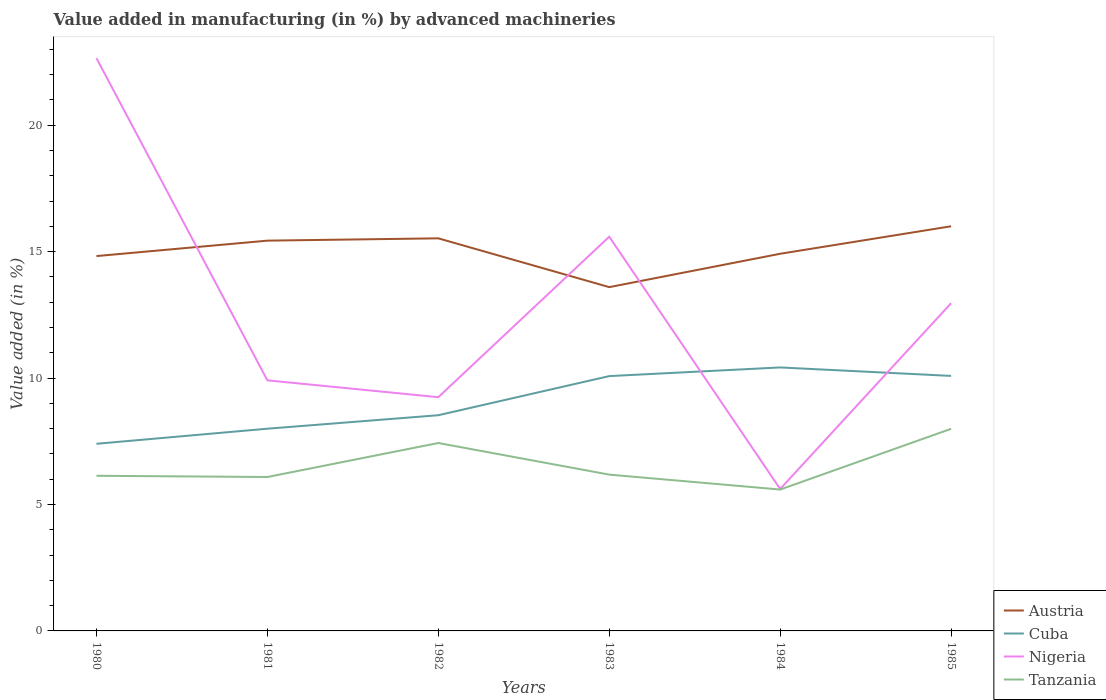How many different coloured lines are there?
Your answer should be very brief. 4. Is the number of lines equal to the number of legend labels?
Your answer should be very brief. Yes. Across all years, what is the maximum percentage of value added in manufacturing by advanced machineries in Cuba?
Your answer should be very brief. 7.4. What is the total percentage of value added in manufacturing by advanced machineries in Tanzania in the graph?
Provide a short and direct response. 0.54. What is the difference between the highest and the second highest percentage of value added in manufacturing by advanced machineries in Tanzania?
Make the answer very short. 2.4. Is the percentage of value added in manufacturing by advanced machineries in Austria strictly greater than the percentage of value added in manufacturing by advanced machineries in Tanzania over the years?
Provide a succinct answer. No. How many lines are there?
Ensure brevity in your answer.  4. How many years are there in the graph?
Your answer should be very brief. 6. What is the difference between two consecutive major ticks on the Y-axis?
Provide a succinct answer. 5. Are the values on the major ticks of Y-axis written in scientific E-notation?
Your response must be concise. No. Does the graph contain any zero values?
Give a very brief answer. No. Where does the legend appear in the graph?
Ensure brevity in your answer.  Bottom right. How many legend labels are there?
Ensure brevity in your answer.  4. What is the title of the graph?
Give a very brief answer. Value added in manufacturing (in %) by advanced machineries. Does "Cote d'Ivoire" appear as one of the legend labels in the graph?
Keep it short and to the point. No. What is the label or title of the Y-axis?
Keep it short and to the point. Value added (in %). What is the Value added (in %) of Austria in 1980?
Ensure brevity in your answer.  14.82. What is the Value added (in %) of Cuba in 1980?
Provide a short and direct response. 7.4. What is the Value added (in %) in Nigeria in 1980?
Your answer should be compact. 22.65. What is the Value added (in %) of Tanzania in 1980?
Provide a succinct answer. 6.14. What is the Value added (in %) of Austria in 1981?
Make the answer very short. 15.43. What is the Value added (in %) of Cuba in 1981?
Your response must be concise. 8. What is the Value added (in %) of Nigeria in 1981?
Your response must be concise. 9.91. What is the Value added (in %) in Tanzania in 1981?
Keep it short and to the point. 6.09. What is the Value added (in %) in Austria in 1982?
Your response must be concise. 15.53. What is the Value added (in %) in Cuba in 1982?
Your answer should be very brief. 8.53. What is the Value added (in %) of Nigeria in 1982?
Keep it short and to the point. 9.24. What is the Value added (in %) of Tanzania in 1982?
Offer a very short reply. 7.43. What is the Value added (in %) in Austria in 1983?
Your response must be concise. 13.6. What is the Value added (in %) of Cuba in 1983?
Offer a very short reply. 10.08. What is the Value added (in %) of Nigeria in 1983?
Offer a very short reply. 15.59. What is the Value added (in %) in Tanzania in 1983?
Offer a very short reply. 6.18. What is the Value added (in %) in Austria in 1984?
Offer a very short reply. 14.92. What is the Value added (in %) of Cuba in 1984?
Make the answer very short. 10.42. What is the Value added (in %) of Nigeria in 1984?
Your answer should be very brief. 5.61. What is the Value added (in %) in Tanzania in 1984?
Keep it short and to the point. 5.59. What is the Value added (in %) of Austria in 1985?
Make the answer very short. 16. What is the Value added (in %) in Cuba in 1985?
Offer a terse response. 10.09. What is the Value added (in %) of Nigeria in 1985?
Make the answer very short. 12.96. What is the Value added (in %) of Tanzania in 1985?
Ensure brevity in your answer.  7.99. Across all years, what is the maximum Value added (in %) in Austria?
Your answer should be compact. 16. Across all years, what is the maximum Value added (in %) in Cuba?
Give a very brief answer. 10.42. Across all years, what is the maximum Value added (in %) in Nigeria?
Your answer should be very brief. 22.65. Across all years, what is the maximum Value added (in %) in Tanzania?
Provide a short and direct response. 7.99. Across all years, what is the minimum Value added (in %) of Austria?
Offer a very short reply. 13.6. Across all years, what is the minimum Value added (in %) in Cuba?
Keep it short and to the point. 7.4. Across all years, what is the minimum Value added (in %) in Nigeria?
Ensure brevity in your answer.  5.61. Across all years, what is the minimum Value added (in %) of Tanzania?
Offer a very short reply. 5.59. What is the total Value added (in %) in Austria in the graph?
Provide a short and direct response. 90.3. What is the total Value added (in %) in Cuba in the graph?
Your answer should be compact. 54.51. What is the total Value added (in %) of Nigeria in the graph?
Provide a short and direct response. 75.97. What is the total Value added (in %) of Tanzania in the graph?
Offer a very short reply. 39.42. What is the difference between the Value added (in %) of Austria in 1980 and that in 1981?
Offer a terse response. -0.61. What is the difference between the Value added (in %) of Cuba in 1980 and that in 1981?
Provide a short and direct response. -0.6. What is the difference between the Value added (in %) of Nigeria in 1980 and that in 1981?
Ensure brevity in your answer.  12.74. What is the difference between the Value added (in %) in Tanzania in 1980 and that in 1981?
Provide a succinct answer. 0.05. What is the difference between the Value added (in %) of Austria in 1980 and that in 1982?
Keep it short and to the point. -0.7. What is the difference between the Value added (in %) in Cuba in 1980 and that in 1982?
Your answer should be very brief. -1.13. What is the difference between the Value added (in %) in Nigeria in 1980 and that in 1982?
Your response must be concise. 13.41. What is the difference between the Value added (in %) of Tanzania in 1980 and that in 1982?
Your answer should be very brief. -1.3. What is the difference between the Value added (in %) of Austria in 1980 and that in 1983?
Provide a short and direct response. 1.23. What is the difference between the Value added (in %) in Cuba in 1980 and that in 1983?
Offer a very short reply. -2.68. What is the difference between the Value added (in %) in Nigeria in 1980 and that in 1983?
Keep it short and to the point. 7.06. What is the difference between the Value added (in %) of Tanzania in 1980 and that in 1983?
Make the answer very short. -0.05. What is the difference between the Value added (in %) in Austria in 1980 and that in 1984?
Your answer should be compact. -0.09. What is the difference between the Value added (in %) in Cuba in 1980 and that in 1984?
Offer a very short reply. -3.02. What is the difference between the Value added (in %) of Nigeria in 1980 and that in 1984?
Give a very brief answer. 17.04. What is the difference between the Value added (in %) in Tanzania in 1980 and that in 1984?
Provide a succinct answer. 0.54. What is the difference between the Value added (in %) of Austria in 1980 and that in 1985?
Keep it short and to the point. -1.18. What is the difference between the Value added (in %) in Cuba in 1980 and that in 1985?
Offer a terse response. -2.69. What is the difference between the Value added (in %) of Nigeria in 1980 and that in 1985?
Your answer should be very brief. 9.69. What is the difference between the Value added (in %) in Tanzania in 1980 and that in 1985?
Your response must be concise. -1.86. What is the difference between the Value added (in %) of Austria in 1981 and that in 1982?
Offer a terse response. -0.09. What is the difference between the Value added (in %) of Cuba in 1981 and that in 1982?
Keep it short and to the point. -0.53. What is the difference between the Value added (in %) of Nigeria in 1981 and that in 1982?
Your answer should be very brief. 0.67. What is the difference between the Value added (in %) in Tanzania in 1981 and that in 1982?
Keep it short and to the point. -1.34. What is the difference between the Value added (in %) in Austria in 1981 and that in 1983?
Provide a succinct answer. 1.84. What is the difference between the Value added (in %) of Cuba in 1981 and that in 1983?
Provide a short and direct response. -2.08. What is the difference between the Value added (in %) in Nigeria in 1981 and that in 1983?
Ensure brevity in your answer.  -5.68. What is the difference between the Value added (in %) in Tanzania in 1981 and that in 1983?
Offer a very short reply. -0.09. What is the difference between the Value added (in %) of Austria in 1981 and that in 1984?
Give a very brief answer. 0.52. What is the difference between the Value added (in %) of Cuba in 1981 and that in 1984?
Your response must be concise. -2.42. What is the difference between the Value added (in %) in Nigeria in 1981 and that in 1984?
Provide a succinct answer. 4.3. What is the difference between the Value added (in %) in Tanzania in 1981 and that in 1984?
Your answer should be compact. 0.5. What is the difference between the Value added (in %) in Austria in 1981 and that in 1985?
Give a very brief answer. -0.57. What is the difference between the Value added (in %) in Cuba in 1981 and that in 1985?
Ensure brevity in your answer.  -2.09. What is the difference between the Value added (in %) of Nigeria in 1981 and that in 1985?
Ensure brevity in your answer.  -3.05. What is the difference between the Value added (in %) in Tanzania in 1981 and that in 1985?
Make the answer very short. -1.91. What is the difference between the Value added (in %) of Austria in 1982 and that in 1983?
Offer a very short reply. 1.93. What is the difference between the Value added (in %) of Cuba in 1982 and that in 1983?
Your response must be concise. -1.55. What is the difference between the Value added (in %) in Nigeria in 1982 and that in 1983?
Your answer should be very brief. -6.35. What is the difference between the Value added (in %) of Tanzania in 1982 and that in 1983?
Keep it short and to the point. 1.25. What is the difference between the Value added (in %) of Austria in 1982 and that in 1984?
Provide a succinct answer. 0.61. What is the difference between the Value added (in %) of Cuba in 1982 and that in 1984?
Give a very brief answer. -1.89. What is the difference between the Value added (in %) of Nigeria in 1982 and that in 1984?
Your answer should be very brief. 3.63. What is the difference between the Value added (in %) of Tanzania in 1982 and that in 1984?
Make the answer very short. 1.84. What is the difference between the Value added (in %) of Austria in 1982 and that in 1985?
Your response must be concise. -0.48. What is the difference between the Value added (in %) of Cuba in 1982 and that in 1985?
Ensure brevity in your answer.  -1.55. What is the difference between the Value added (in %) of Nigeria in 1982 and that in 1985?
Ensure brevity in your answer.  -3.72. What is the difference between the Value added (in %) of Tanzania in 1982 and that in 1985?
Offer a terse response. -0.56. What is the difference between the Value added (in %) in Austria in 1983 and that in 1984?
Offer a terse response. -1.32. What is the difference between the Value added (in %) in Cuba in 1983 and that in 1984?
Make the answer very short. -0.34. What is the difference between the Value added (in %) of Nigeria in 1983 and that in 1984?
Provide a short and direct response. 9.98. What is the difference between the Value added (in %) in Tanzania in 1983 and that in 1984?
Keep it short and to the point. 0.59. What is the difference between the Value added (in %) of Austria in 1983 and that in 1985?
Keep it short and to the point. -2.41. What is the difference between the Value added (in %) of Cuba in 1983 and that in 1985?
Your answer should be very brief. -0.01. What is the difference between the Value added (in %) of Nigeria in 1983 and that in 1985?
Provide a succinct answer. 2.63. What is the difference between the Value added (in %) of Tanzania in 1983 and that in 1985?
Provide a short and direct response. -1.81. What is the difference between the Value added (in %) of Austria in 1984 and that in 1985?
Provide a succinct answer. -1.09. What is the difference between the Value added (in %) of Cuba in 1984 and that in 1985?
Your response must be concise. 0.33. What is the difference between the Value added (in %) in Nigeria in 1984 and that in 1985?
Give a very brief answer. -7.35. What is the difference between the Value added (in %) in Tanzania in 1984 and that in 1985?
Offer a terse response. -2.4. What is the difference between the Value added (in %) of Austria in 1980 and the Value added (in %) of Cuba in 1981?
Provide a succinct answer. 6.83. What is the difference between the Value added (in %) in Austria in 1980 and the Value added (in %) in Nigeria in 1981?
Your response must be concise. 4.91. What is the difference between the Value added (in %) of Austria in 1980 and the Value added (in %) of Tanzania in 1981?
Offer a terse response. 8.74. What is the difference between the Value added (in %) in Cuba in 1980 and the Value added (in %) in Nigeria in 1981?
Provide a short and direct response. -2.51. What is the difference between the Value added (in %) in Cuba in 1980 and the Value added (in %) in Tanzania in 1981?
Your answer should be very brief. 1.31. What is the difference between the Value added (in %) of Nigeria in 1980 and the Value added (in %) of Tanzania in 1981?
Keep it short and to the point. 16.56. What is the difference between the Value added (in %) in Austria in 1980 and the Value added (in %) in Cuba in 1982?
Offer a very short reply. 6.29. What is the difference between the Value added (in %) in Austria in 1980 and the Value added (in %) in Nigeria in 1982?
Keep it short and to the point. 5.58. What is the difference between the Value added (in %) in Austria in 1980 and the Value added (in %) in Tanzania in 1982?
Keep it short and to the point. 7.39. What is the difference between the Value added (in %) of Cuba in 1980 and the Value added (in %) of Nigeria in 1982?
Your answer should be very brief. -1.84. What is the difference between the Value added (in %) of Cuba in 1980 and the Value added (in %) of Tanzania in 1982?
Offer a very short reply. -0.03. What is the difference between the Value added (in %) of Nigeria in 1980 and the Value added (in %) of Tanzania in 1982?
Offer a terse response. 15.22. What is the difference between the Value added (in %) of Austria in 1980 and the Value added (in %) of Cuba in 1983?
Your answer should be compact. 4.75. What is the difference between the Value added (in %) in Austria in 1980 and the Value added (in %) in Nigeria in 1983?
Offer a terse response. -0.77. What is the difference between the Value added (in %) of Austria in 1980 and the Value added (in %) of Tanzania in 1983?
Give a very brief answer. 8.64. What is the difference between the Value added (in %) of Cuba in 1980 and the Value added (in %) of Nigeria in 1983?
Your response must be concise. -8.19. What is the difference between the Value added (in %) in Cuba in 1980 and the Value added (in %) in Tanzania in 1983?
Your answer should be compact. 1.22. What is the difference between the Value added (in %) of Nigeria in 1980 and the Value added (in %) of Tanzania in 1983?
Provide a short and direct response. 16.47. What is the difference between the Value added (in %) in Austria in 1980 and the Value added (in %) in Cuba in 1984?
Your answer should be very brief. 4.4. What is the difference between the Value added (in %) of Austria in 1980 and the Value added (in %) of Nigeria in 1984?
Your answer should be compact. 9.21. What is the difference between the Value added (in %) of Austria in 1980 and the Value added (in %) of Tanzania in 1984?
Give a very brief answer. 9.23. What is the difference between the Value added (in %) of Cuba in 1980 and the Value added (in %) of Nigeria in 1984?
Keep it short and to the point. 1.79. What is the difference between the Value added (in %) of Cuba in 1980 and the Value added (in %) of Tanzania in 1984?
Offer a very short reply. 1.81. What is the difference between the Value added (in %) in Nigeria in 1980 and the Value added (in %) in Tanzania in 1984?
Ensure brevity in your answer.  17.06. What is the difference between the Value added (in %) of Austria in 1980 and the Value added (in %) of Cuba in 1985?
Give a very brief answer. 4.74. What is the difference between the Value added (in %) of Austria in 1980 and the Value added (in %) of Nigeria in 1985?
Give a very brief answer. 1.86. What is the difference between the Value added (in %) of Austria in 1980 and the Value added (in %) of Tanzania in 1985?
Your answer should be compact. 6.83. What is the difference between the Value added (in %) in Cuba in 1980 and the Value added (in %) in Nigeria in 1985?
Offer a terse response. -5.56. What is the difference between the Value added (in %) of Cuba in 1980 and the Value added (in %) of Tanzania in 1985?
Your response must be concise. -0.59. What is the difference between the Value added (in %) of Nigeria in 1980 and the Value added (in %) of Tanzania in 1985?
Keep it short and to the point. 14.66. What is the difference between the Value added (in %) of Austria in 1981 and the Value added (in %) of Cuba in 1982?
Ensure brevity in your answer.  6.9. What is the difference between the Value added (in %) of Austria in 1981 and the Value added (in %) of Nigeria in 1982?
Your answer should be compact. 6.19. What is the difference between the Value added (in %) of Austria in 1981 and the Value added (in %) of Tanzania in 1982?
Your answer should be very brief. 8. What is the difference between the Value added (in %) of Cuba in 1981 and the Value added (in %) of Nigeria in 1982?
Provide a succinct answer. -1.25. What is the difference between the Value added (in %) in Cuba in 1981 and the Value added (in %) in Tanzania in 1982?
Give a very brief answer. 0.57. What is the difference between the Value added (in %) in Nigeria in 1981 and the Value added (in %) in Tanzania in 1982?
Keep it short and to the point. 2.48. What is the difference between the Value added (in %) of Austria in 1981 and the Value added (in %) of Cuba in 1983?
Keep it short and to the point. 5.36. What is the difference between the Value added (in %) of Austria in 1981 and the Value added (in %) of Nigeria in 1983?
Offer a very short reply. -0.16. What is the difference between the Value added (in %) of Austria in 1981 and the Value added (in %) of Tanzania in 1983?
Ensure brevity in your answer.  9.25. What is the difference between the Value added (in %) in Cuba in 1981 and the Value added (in %) in Nigeria in 1983?
Offer a terse response. -7.59. What is the difference between the Value added (in %) of Cuba in 1981 and the Value added (in %) of Tanzania in 1983?
Provide a short and direct response. 1.82. What is the difference between the Value added (in %) in Nigeria in 1981 and the Value added (in %) in Tanzania in 1983?
Provide a short and direct response. 3.73. What is the difference between the Value added (in %) in Austria in 1981 and the Value added (in %) in Cuba in 1984?
Ensure brevity in your answer.  5.01. What is the difference between the Value added (in %) of Austria in 1981 and the Value added (in %) of Nigeria in 1984?
Provide a succinct answer. 9.82. What is the difference between the Value added (in %) in Austria in 1981 and the Value added (in %) in Tanzania in 1984?
Ensure brevity in your answer.  9.84. What is the difference between the Value added (in %) in Cuba in 1981 and the Value added (in %) in Nigeria in 1984?
Make the answer very short. 2.38. What is the difference between the Value added (in %) in Cuba in 1981 and the Value added (in %) in Tanzania in 1984?
Provide a succinct answer. 2.41. What is the difference between the Value added (in %) in Nigeria in 1981 and the Value added (in %) in Tanzania in 1984?
Offer a very short reply. 4.32. What is the difference between the Value added (in %) in Austria in 1981 and the Value added (in %) in Cuba in 1985?
Provide a short and direct response. 5.35. What is the difference between the Value added (in %) of Austria in 1981 and the Value added (in %) of Nigeria in 1985?
Your answer should be compact. 2.47. What is the difference between the Value added (in %) of Austria in 1981 and the Value added (in %) of Tanzania in 1985?
Keep it short and to the point. 7.44. What is the difference between the Value added (in %) in Cuba in 1981 and the Value added (in %) in Nigeria in 1985?
Offer a terse response. -4.96. What is the difference between the Value added (in %) of Cuba in 1981 and the Value added (in %) of Tanzania in 1985?
Your answer should be very brief. 0. What is the difference between the Value added (in %) of Nigeria in 1981 and the Value added (in %) of Tanzania in 1985?
Your response must be concise. 1.92. What is the difference between the Value added (in %) in Austria in 1982 and the Value added (in %) in Cuba in 1983?
Make the answer very short. 5.45. What is the difference between the Value added (in %) of Austria in 1982 and the Value added (in %) of Nigeria in 1983?
Ensure brevity in your answer.  -0.06. What is the difference between the Value added (in %) in Austria in 1982 and the Value added (in %) in Tanzania in 1983?
Your answer should be compact. 9.34. What is the difference between the Value added (in %) in Cuba in 1982 and the Value added (in %) in Nigeria in 1983?
Ensure brevity in your answer.  -7.06. What is the difference between the Value added (in %) of Cuba in 1982 and the Value added (in %) of Tanzania in 1983?
Your answer should be compact. 2.35. What is the difference between the Value added (in %) in Nigeria in 1982 and the Value added (in %) in Tanzania in 1983?
Your answer should be compact. 3.06. What is the difference between the Value added (in %) in Austria in 1982 and the Value added (in %) in Cuba in 1984?
Your answer should be very brief. 5.11. What is the difference between the Value added (in %) in Austria in 1982 and the Value added (in %) in Nigeria in 1984?
Your response must be concise. 9.91. What is the difference between the Value added (in %) in Austria in 1982 and the Value added (in %) in Tanzania in 1984?
Your answer should be very brief. 9.93. What is the difference between the Value added (in %) in Cuba in 1982 and the Value added (in %) in Nigeria in 1984?
Keep it short and to the point. 2.92. What is the difference between the Value added (in %) in Cuba in 1982 and the Value added (in %) in Tanzania in 1984?
Provide a succinct answer. 2.94. What is the difference between the Value added (in %) in Nigeria in 1982 and the Value added (in %) in Tanzania in 1984?
Keep it short and to the point. 3.65. What is the difference between the Value added (in %) in Austria in 1982 and the Value added (in %) in Cuba in 1985?
Provide a short and direct response. 5.44. What is the difference between the Value added (in %) in Austria in 1982 and the Value added (in %) in Nigeria in 1985?
Your answer should be very brief. 2.57. What is the difference between the Value added (in %) of Austria in 1982 and the Value added (in %) of Tanzania in 1985?
Make the answer very short. 7.53. What is the difference between the Value added (in %) in Cuba in 1982 and the Value added (in %) in Nigeria in 1985?
Your answer should be compact. -4.43. What is the difference between the Value added (in %) of Cuba in 1982 and the Value added (in %) of Tanzania in 1985?
Offer a terse response. 0.54. What is the difference between the Value added (in %) of Nigeria in 1982 and the Value added (in %) of Tanzania in 1985?
Keep it short and to the point. 1.25. What is the difference between the Value added (in %) in Austria in 1983 and the Value added (in %) in Cuba in 1984?
Your answer should be very brief. 3.18. What is the difference between the Value added (in %) of Austria in 1983 and the Value added (in %) of Nigeria in 1984?
Your answer should be compact. 7.98. What is the difference between the Value added (in %) of Austria in 1983 and the Value added (in %) of Tanzania in 1984?
Your answer should be compact. 8.01. What is the difference between the Value added (in %) in Cuba in 1983 and the Value added (in %) in Nigeria in 1984?
Your response must be concise. 4.46. What is the difference between the Value added (in %) of Cuba in 1983 and the Value added (in %) of Tanzania in 1984?
Provide a short and direct response. 4.49. What is the difference between the Value added (in %) in Nigeria in 1983 and the Value added (in %) in Tanzania in 1984?
Provide a short and direct response. 10. What is the difference between the Value added (in %) of Austria in 1983 and the Value added (in %) of Cuba in 1985?
Offer a very short reply. 3.51. What is the difference between the Value added (in %) in Austria in 1983 and the Value added (in %) in Nigeria in 1985?
Your answer should be compact. 0.64. What is the difference between the Value added (in %) of Austria in 1983 and the Value added (in %) of Tanzania in 1985?
Keep it short and to the point. 5.6. What is the difference between the Value added (in %) of Cuba in 1983 and the Value added (in %) of Nigeria in 1985?
Make the answer very short. -2.88. What is the difference between the Value added (in %) in Cuba in 1983 and the Value added (in %) in Tanzania in 1985?
Provide a succinct answer. 2.08. What is the difference between the Value added (in %) of Nigeria in 1983 and the Value added (in %) of Tanzania in 1985?
Make the answer very short. 7.6. What is the difference between the Value added (in %) in Austria in 1984 and the Value added (in %) in Cuba in 1985?
Your response must be concise. 4.83. What is the difference between the Value added (in %) of Austria in 1984 and the Value added (in %) of Nigeria in 1985?
Your answer should be compact. 1.96. What is the difference between the Value added (in %) of Austria in 1984 and the Value added (in %) of Tanzania in 1985?
Your response must be concise. 6.92. What is the difference between the Value added (in %) of Cuba in 1984 and the Value added (in %) of Nigeria in 1985?
Provide a short and direct response. -2.54. What is the difference between the Value added (in %) of Cuba in 1984 and the Value added (in %) of Tanzania in 1985?
Provide a succinct answer. 2.43. What is the difference between the Value added (in %) of Nigeria in 1984 and the Value added (in %) of Tanzania in 1985?
Provide a short and direct response. -2.38. What is the average Value added (in %) of Austria per year?
Offer a very short reply. 15.05. What is the average Value added (in %) in Cuba per year?
Ensure brevity in your answer.  9.09. What is the average Value added (in %) in Nigeria per year?
Ensure brevity in your answer.  12.66. What is the average Value added (in %) in Tanzania per year?
Offer a very short reply. 6.57. In the year 1980, what is the difference between the Value added (in %) of Austria and Value added (in %) of Cuba?
Your answer should be very brief. 7.42. In the year 1980, what is the difference between the Value added (in %) of Austria and Value added (in %) of Nigeria?
Offer a terse response. -7.83. In the year 1980, what is the difference between the Value added (in %) of Austria and Value added (in %) of Tanzania?
Your answer should be compact. 8.69. In the year 1980, what is the difference between the Value added (in %) in Cuba and Value added (in %) in Nigeria?
Ensure brevity in your answer.  -15.25. In the year 1980, what is the difference between the Value added (in %) in Cuba and Value added (in %) in Tanzania?
Ensure brevity in your answer.  1.27. In the year 1980, what is the difference between the Value added (in %) in Nigeria and Value added (in %) in Tanzania?
Keep it short and to the point. 16.52. In the year 1981, what is the difference between the Value added (in %) in Austria and Value added (in %) in Cuba?
Your response must be concise. 7.44. In the year 1981, what is the difference between the Value added (in %) of Austria and Value added (in %) of Nigeria?
Provide a short and direct response. 5.52. In the year 1981, what is the difference between the Value added (in %) in Austria and Value added (in %) in Tanzania?
Your answer should be very brief. 9.35. In the year 1981, what is the difference between the Value added (in %) of Cuba and Value added (in %) of Nigeria?
Your response must be concise. -1.91. In the year 1981, what is the difference between the Value added (in %) in Cuba and Value added (in %) in Tanzania?
Your answer should be compact. 1.91. In the year 1981, what is the difference between the Value added (in %) in Nigeria and Value added (in %) in Tanzania?
Keep it short and to the point. 3.82. In the year 1982, what is the difference between the Value added (in %) of Austria and Value added (in %) of Cuba?
Ensure brevity in your answer.  7. In the year 1982, what is the difference between the Value added (in %) in Austria and Value added (in %) in Nigeria?
Your response must be concise. 6.28. In the year 1982, what is the difference between the Value added (in %) in Austria and Value added (in %) in Tanzania?
Your response must be concise. 8.09. In the year 1982, what is the difference between the Value added (in %) in Cuba and Value added (in %) in Nigeria?
Make the answer very short. -0.71. In the year 1982, what is the difference between the Value added (in %) in Cuba and Value added (in %) in Tanzania?
Make the answer very short. 1.1. In the year 1982, what is the difference between the Value added (in %) of Nigeria and Value added (in %) of Tanzania?
Keep it short and to the point. 1.81. In the year 1983, what is the difference between the Value added (in %) of Austria and Value added (in %) of Cuba?
Ensure brevity in your answer.  3.52. In the year 1983, what is the difference between the Value added (in %) of Austria and Value added (in %) of Nigeria?
Offer a terse response. -1.99. In the year 1983, what is the difference between the Value added (in %) in Austria and Value added (in %) in Tanzania?
Offer a very short reply. 7.42. In the year 1983, what is the difference between the Value added (in %) of Cuba and Value added (in %) of Nigeria?
Offer a terse response. -5.51. In the year 1983, what is the difference between the Value added (in %) of Cuba and Value added (in %) of Tanzania?
Keep it short and to the point. 3.9. In the year 1983, what is the difference between the Value added (in %) in Nigeria and Value added (in %) in Tanzania?
Your answer should be very brief. 9.41. In the year 1984, what is the difference between the Value added (in %) of Austria and Value added (in %) of Cuba?
Ensure brevity in your answer.  4.5. In the year 1984, what is the difference between the Value added (in %) of Austria and Value added (in %) of Nigeria?
Keep it short and to the point. 9.3. In the year 1984, what is the difference between the Value added (in %) in Austria and Value added (in %) in Tanzania?
Your answer should be very brief. 9.32. In the year 1984, what is the difference between the Value added (in %) in Cuba and Value added (in %) in Nigeria?
Offer a very short reply. 4.81. In the year 1984, what is the difference between the Value added (in %) in Cuba and Value added (in %) in Tanzania?
Your answer should be very brief. 4.83. In the year 1984, what is the difference between the Value added (in %) in Nigeria and Value added (in %) in Tanzania?
Your response must be concise. 0.02. In the year 1985, what is the difference between the Value added (in %) in Austria and Value added (in %) in Cuba?
Keep it short and to the point. 5.92. In the year 1985, what is the difference between the Value added (in %) of Austria and Value added (in %) of Nigeria?
Ensure brevity in your answer.  3.04. In the year 1985, what is the difference between the Value added (in %) in Austria and Value added (in %) in Tanzania?
Your response must be concise. 8.01. In the year 1985, what is the difference between the Value added (in %) in Cuba and Value added (in %) in Nigeria?
Ensure brevity in your answer.  -2.88. In the year 1985, what is the difference between the Value added (in %) in Cuba and Value added (in %) in Tanzania?
Offer a terse response. 2.09. In the year 1985, what is the difference between the Value added (in %) of Nigeria and Value added (in %) of Tanzania?
Offer a very short reply. 4.97. What is the ratio of the Value added (in %) in Austria in 1980 to that in 1981?
Provide a short and direct response. 0.96. What is the ratio of the Value added (in %) of Cuba in 1980 to that in 1981?
Keep it short and to the point. 0.93. What is the ratio of the Value added (in %) of Nigeria in 1980 to that in 1981?
Your answer should be very brief. 2.29. What is the ratio of the Value added (in %) in Tanzania in 1980 to that in 1981?
Your response must be concise. 1.01. What is the ratio of the Value added (in %) in Austria in 1980 to that in 1982?
Keep it short and to the point. 0.95. What is the ratio of the Value added (in %) of Cuba in 1980 to that in 1982?
Give a very brief answer. 0.87. What is the ratio of the Value added (in %) in Nigeria in 1980 to that in 1982?
Your answer should be compact. 2.45. What is the ratio of the Value added (in %) of Tanzania in 1980 to that in 1982?
Offer a terse response. 0.83. What is the ratio of the Value added (in %) in Austria in 1980 to that in 1983?
Give a very brief answer. 1.09. What is the ratio of the Value added (in %) of Cuba in 1980 to that in 1983?
Provide a succinct answer. 0.73. What is the ratio of the Value added (in %) of Nigeria in 1980 to that in 1983?
Offer a very short reply. 1.45. What is the ratio of the Value added (in %) in Cuba in 1980 to that in 1984?
Offer a terse response. 0.71. What is the ratio of the Value added (in %) of Nigeria in 1980 to that in 1984?
Give a very brief answer. 4.04. What is the ratio of the Value added (in %) of Tanzania in 1980 to that in 1984?
Ensure brevity in your answer.  1.1. What is the ratio of the Value added (in %) in Austria in 1980 to that in 1985?
Provide a succinct answer. 0.93. What is the ratio of the Value added (in %) in Cuba in 1980 to that in 1985?
Offer a very short reply. 0.73. What is the ratio of the Value added (in %) of Nigeria in 1980 to that in 1985?
Your answer should be very brief. 1.75. What is the ratio of the Value added (in %) in Tanzania in 1980 to that in 1985?
Your response must be concise. 0.77. What is the ratio of the Value added (in %) of Nigeria in 1981 to that in 1982?
Your response must be concise. 1.07. What is the ratio of the Value added (in %) of Tanzania in 1981 to that in 1982?
Ensure brevity in your answer.  0.82. What is the ratio of the Value added (in %) of Austria in 1981 to that in 1983?
Your response must be concise. 1.14. What is the ratio of the Value added (in %) of Cuba in 1981 to that in 1983?
Your response must be concise. 0.79. What is the ratio of the Value added (in %) in Nigeria in 1981 to that in 1983?
Make the answer very short. 0.64. What is the ratio of the Value added (in %) of Austria in 1981 to that in 1984?
Your answer should be very brief. 1.03. What is the ratio of the Value added (in %) in Cuba in 1981 to that in 1984?
Offer a very short reply. 0.77. What is the ratio of the Value added (in %) in Nigeria in 1981 to that in 1984?
Offer a terse response. 1.77. What is the ratio of the Value added (in %) of Tanzania in 1981 to that in 1984?
Your answer should be compact. 1.09. What is the ratio of the Value added (in %) in Austria in 1981 to that in 1985?
Provide a succinct answer. 0.96. What is the ratio of the Value added (in %) in Cuba in 1981 to that in 1985?
Offer a terse response. 0.79. What is the ratio of the Value added (in %) of Nigeria in 1981 to that in 1985?
Ensure brevity in your answer.  0.76. What is the ratio of the Value added (in %) in Tanzania in 1981 to that in 1985?
Your response must be concise. 0.76. What is the ratio of the Value added (in %) in Austria in 1982 to that in 1983?
Your answer should be compact. 1.14. What is the ratio of the Value added (in %) in Cuba in 1982 to that in 1983?
Offer a very short reply. 0.85. What is the ratio of the Value added (in %) in Nigeria in 1982 to that in 1983?
Give a very brief answer. 0.59. What is the ratio of the Value added (in %) in Tanzania in 1982 to that in 1983?
Provide a short and direct response. 1.2. What is the ratio of the Value added (in %) of Austria in 1982 to that in 1984?
Offer a terse response. 1.04. What is the ratio of the Value added (in %) in Cuba in 1982 to that in 1984?
Keep it short and to the point. 0.82. What is the ratio of the Value added (in %) of Nigeria in 1982 to that in 1984?
Provide a succinct answer. 1.65. What is the ratio of the Value added (in %) of Tanzania in 1982 to that in 1984?
Your answer should be very brief. 1.33. What is the ratio of the Value added (in %) in Austria in 1982 to that in 1985?
Your answer should be compact. 0.97. What is the ratio of the Value added (in %) of Cuba in 1982 to that in 1985?
Make the answer very short. 0.85. What is the ratio of the Value added (in %) in Nigeria in 1982 to that in 1985?
Provide a short and direct response. 0.71. What is the ratio of the Value added (in %) in Tanzania in 1982 to that in 1985?
Offer a very short reply. 0.93. What is the ratio of the Value added (in %) in Austria in 1983 to that in 1984?
Provide a succinct answer. 0.91. What is the ratio of the Value added (in %) of Cuba in 1983 to that in 1984?
Provide a short and direct response. 0.97. What is the ratio of the Value added (in %) of Nigeria in 1983 to that in 1984?
Give a very brief answer. 2.78. What is the ratio of the Value added (in %) of Tanzania in 1983 to that in 1984?
Keep it short and to the point. 1.11. What is the ratio of the Value added (in %) in Austria in 1983 to that in 1985?
Keep it short and to the point. 0.85. What is the ratio of the Value added (in %) of Nigeria in 1983 to that in 1985?
Offer a terse response. 1.2. What is the ratio of the Value added (in %) of Tanzania in 1983 to that in 1985?
Make the answer very short. 0.77. What is the ratio of the Value added (in %) of Austria in 1984 to that in 1985?
Your answer should be very brief. 0.93. What is the ratio of the Value added (in %) of Cuba in 1984 to that in 1985?
Make the answer very short. 1.03. What is the ratio of the Value added (in %) in Nigeria in 1984 to that in 1985?
Your answer should be compact. 0.43. What is the ratio of the Value added (in %) in Tanzania in 1984 to that in 1985?
Provide a succinct answer. 0.7. What is the difference between the highest and the second highest Value added (in %) of Austria?
Your answer should be compact. 0.48. What is the difference between the highest and the second highest Value added (in %) in Cuba?
Provide a succinct answer. 0.33. What is the difference between the highest and the second highest Value added (in %) of Nigeria?
Give a very brief answer. 7.06. What is the difference between the highest and the second highest Value added (in %) in Tanzania?
Your answer should be very brief. 0.56. What is the difference between the highest and the lowest Value added (in %) of Austria?
Your answer should be very brief. 2.41. What is the difference between the highest and the lowest Value added (in %) of Cuba?
Your answer should be very brief. 3.02. What is the difference between the highest and the lowest Value added (in %) in Nigeria?
Make the answer very short. 17.04. What is the difference between the highest and the lowest Value added (in %) of Tanzania?
Give a very brief answer. 2.4. 